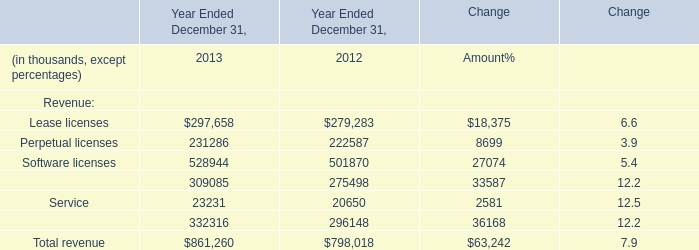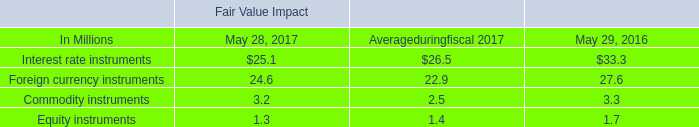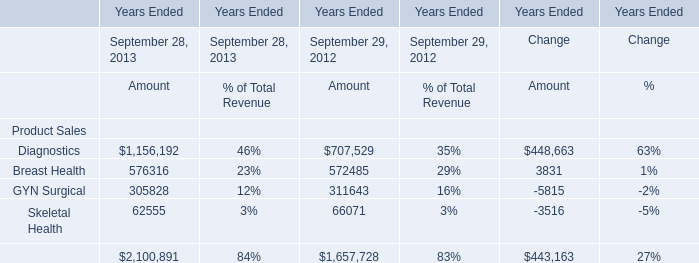If Total revenue develops with the same growth rate in 2013, what will it reach in 2014? (in thousand) 
Computations: ((((798018 - 861260) / 798018) * 861260) + 861260)
Answer: 793006.14492. 